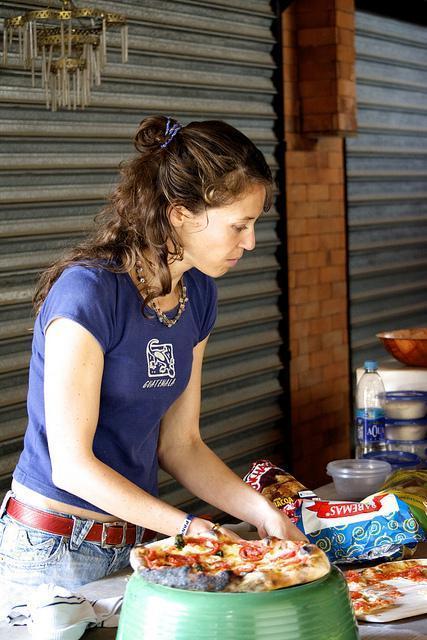How many pizzas are there?
Give a very brief answer. 3. How many of the posts ahve clocks on them?
Give a very brief answer. 0. 